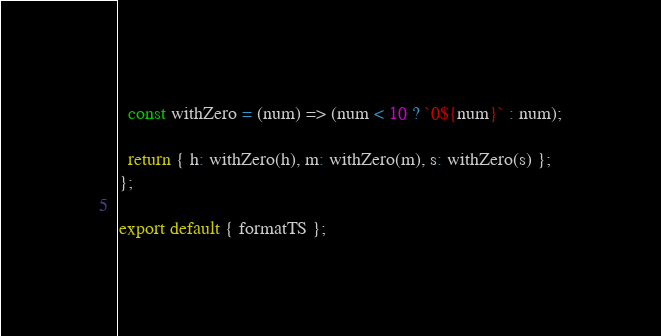<code> <loc_0><loc_0><loc_500><loc_500><_JavaScript_>  const withZero = (num) => (num < 10 ? `0${num}` : num);

  return { h: withZero(h), m: withZero(m), s: withZero(s) };
};

export default { formatTS };
</code> 